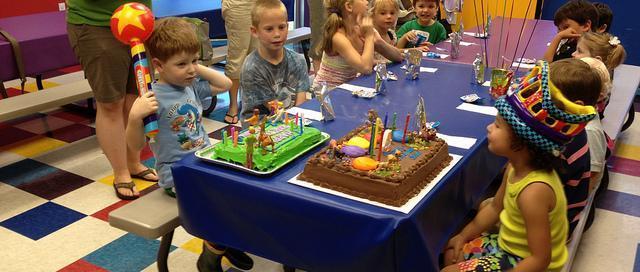How many cakes on the table?
Give a very brief answer. 2. How many cakes are there?
Give a very brief answer. 2. How many people are in the photo?
Give a very brief answer. 8. How many benches can you see?
Give a very brief answer. 2. How many dining tables are in the picture?
Give a very brief answer. 2. 